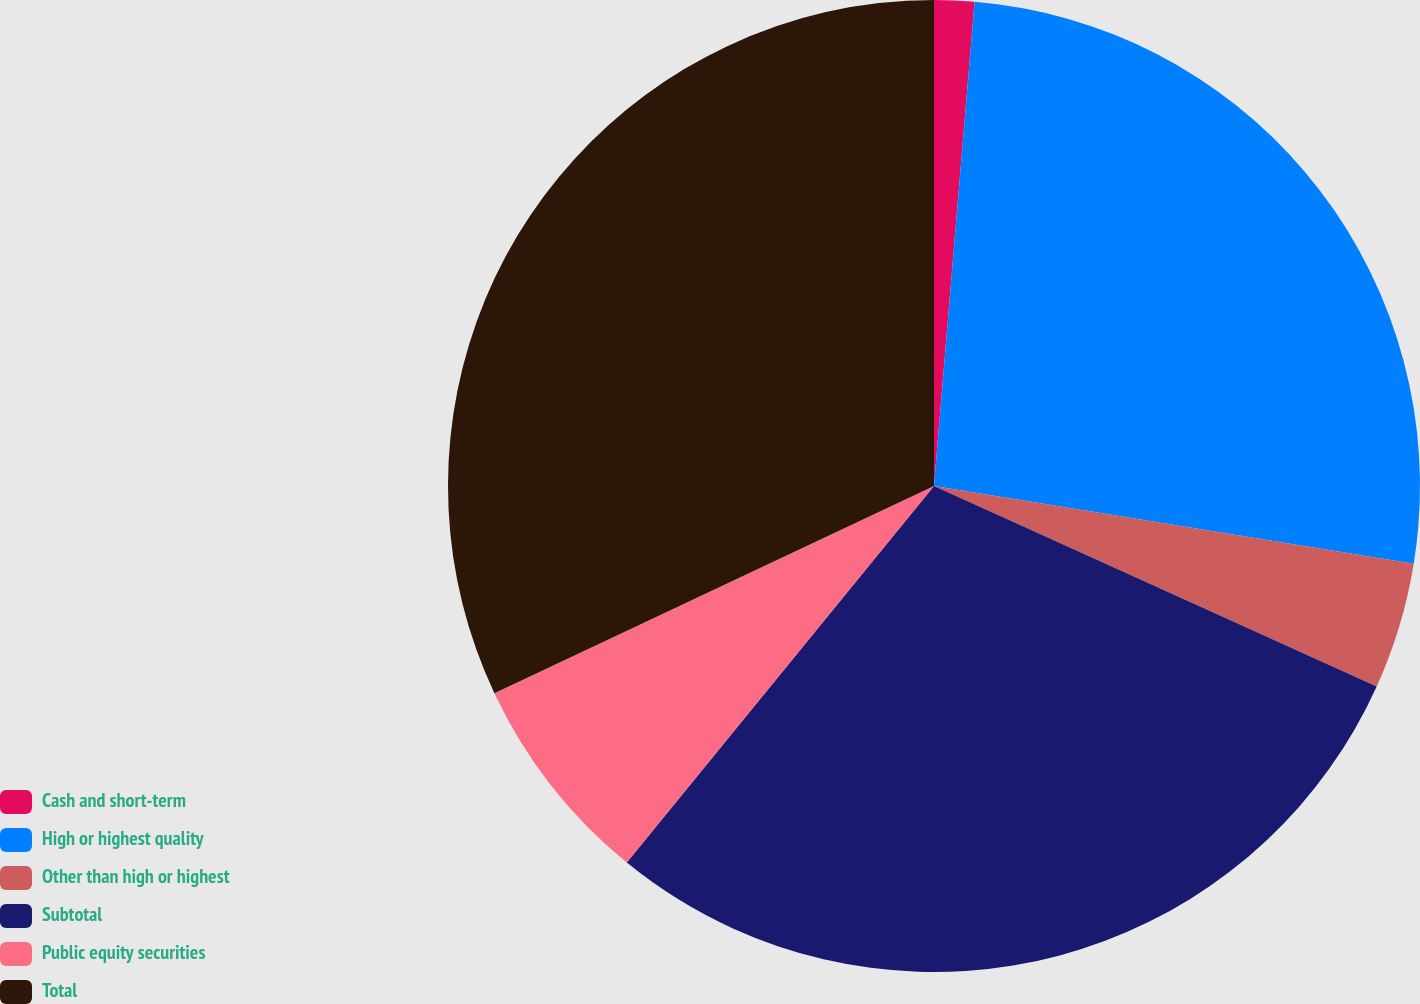Convert chart. <chart><loc_0><loc_0><loc_500><loc_500><pie_chart><fcel>Cash and short-term<fcel>High or highest quality<fcel>Other than high or highest<fcel>Subtotal<fcel>Public equity securities<fcel>Total<nl><fcel>1.33%<fcel>26.23%<fcel>4.21%<fcel>29.12%<fcel>7.1%<fcel>32.01%<nl></chart> 